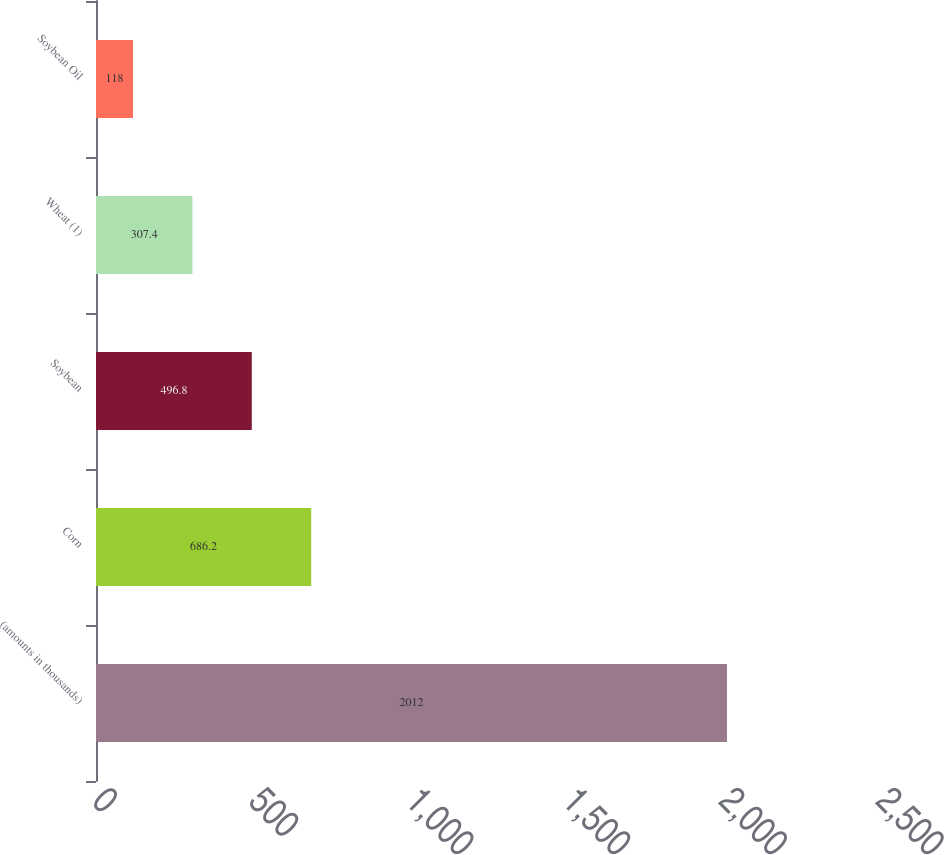Convert chart. <chart><loc_0><loc_0><loc_500><loc_500><bar_chart><fcel>(amounts in thousands)<fcel>Corn<fcel>Soybean<fcel>Wheat (1)<fcel>Soybean Oil<nl><fcel>2012<fcel>686.2<fcel>496.8<fcel>307.4<fcel>118<nl></chart> 